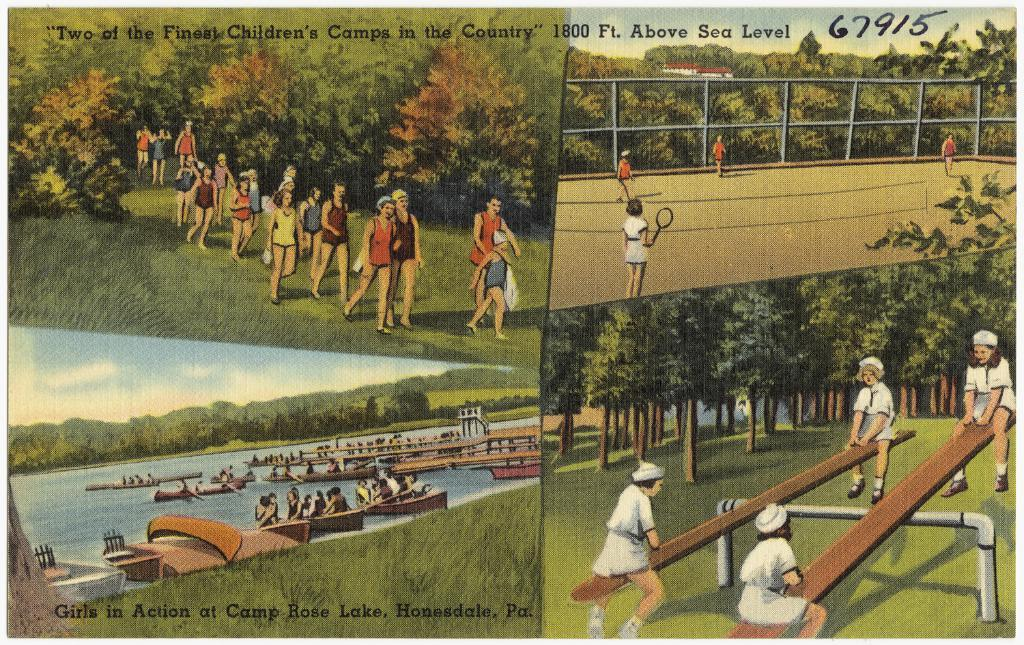<image>
Offer a succinct explanation of the picture presented. An advertisement that is labeled as "Two of the Finest Children's Camps in the Country" 